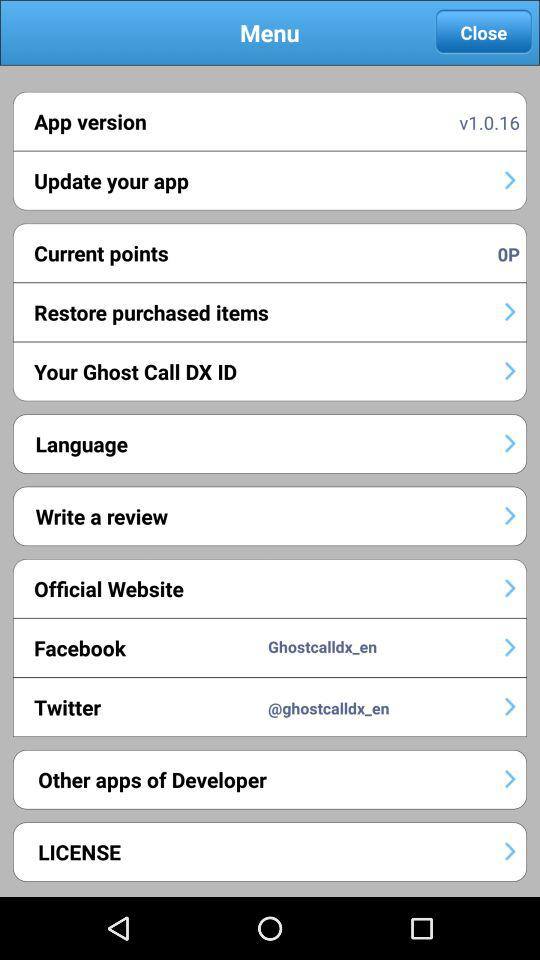What is the username used for "Facebook"? The username used for "Facebook" is "Ghostcalldx_en". 